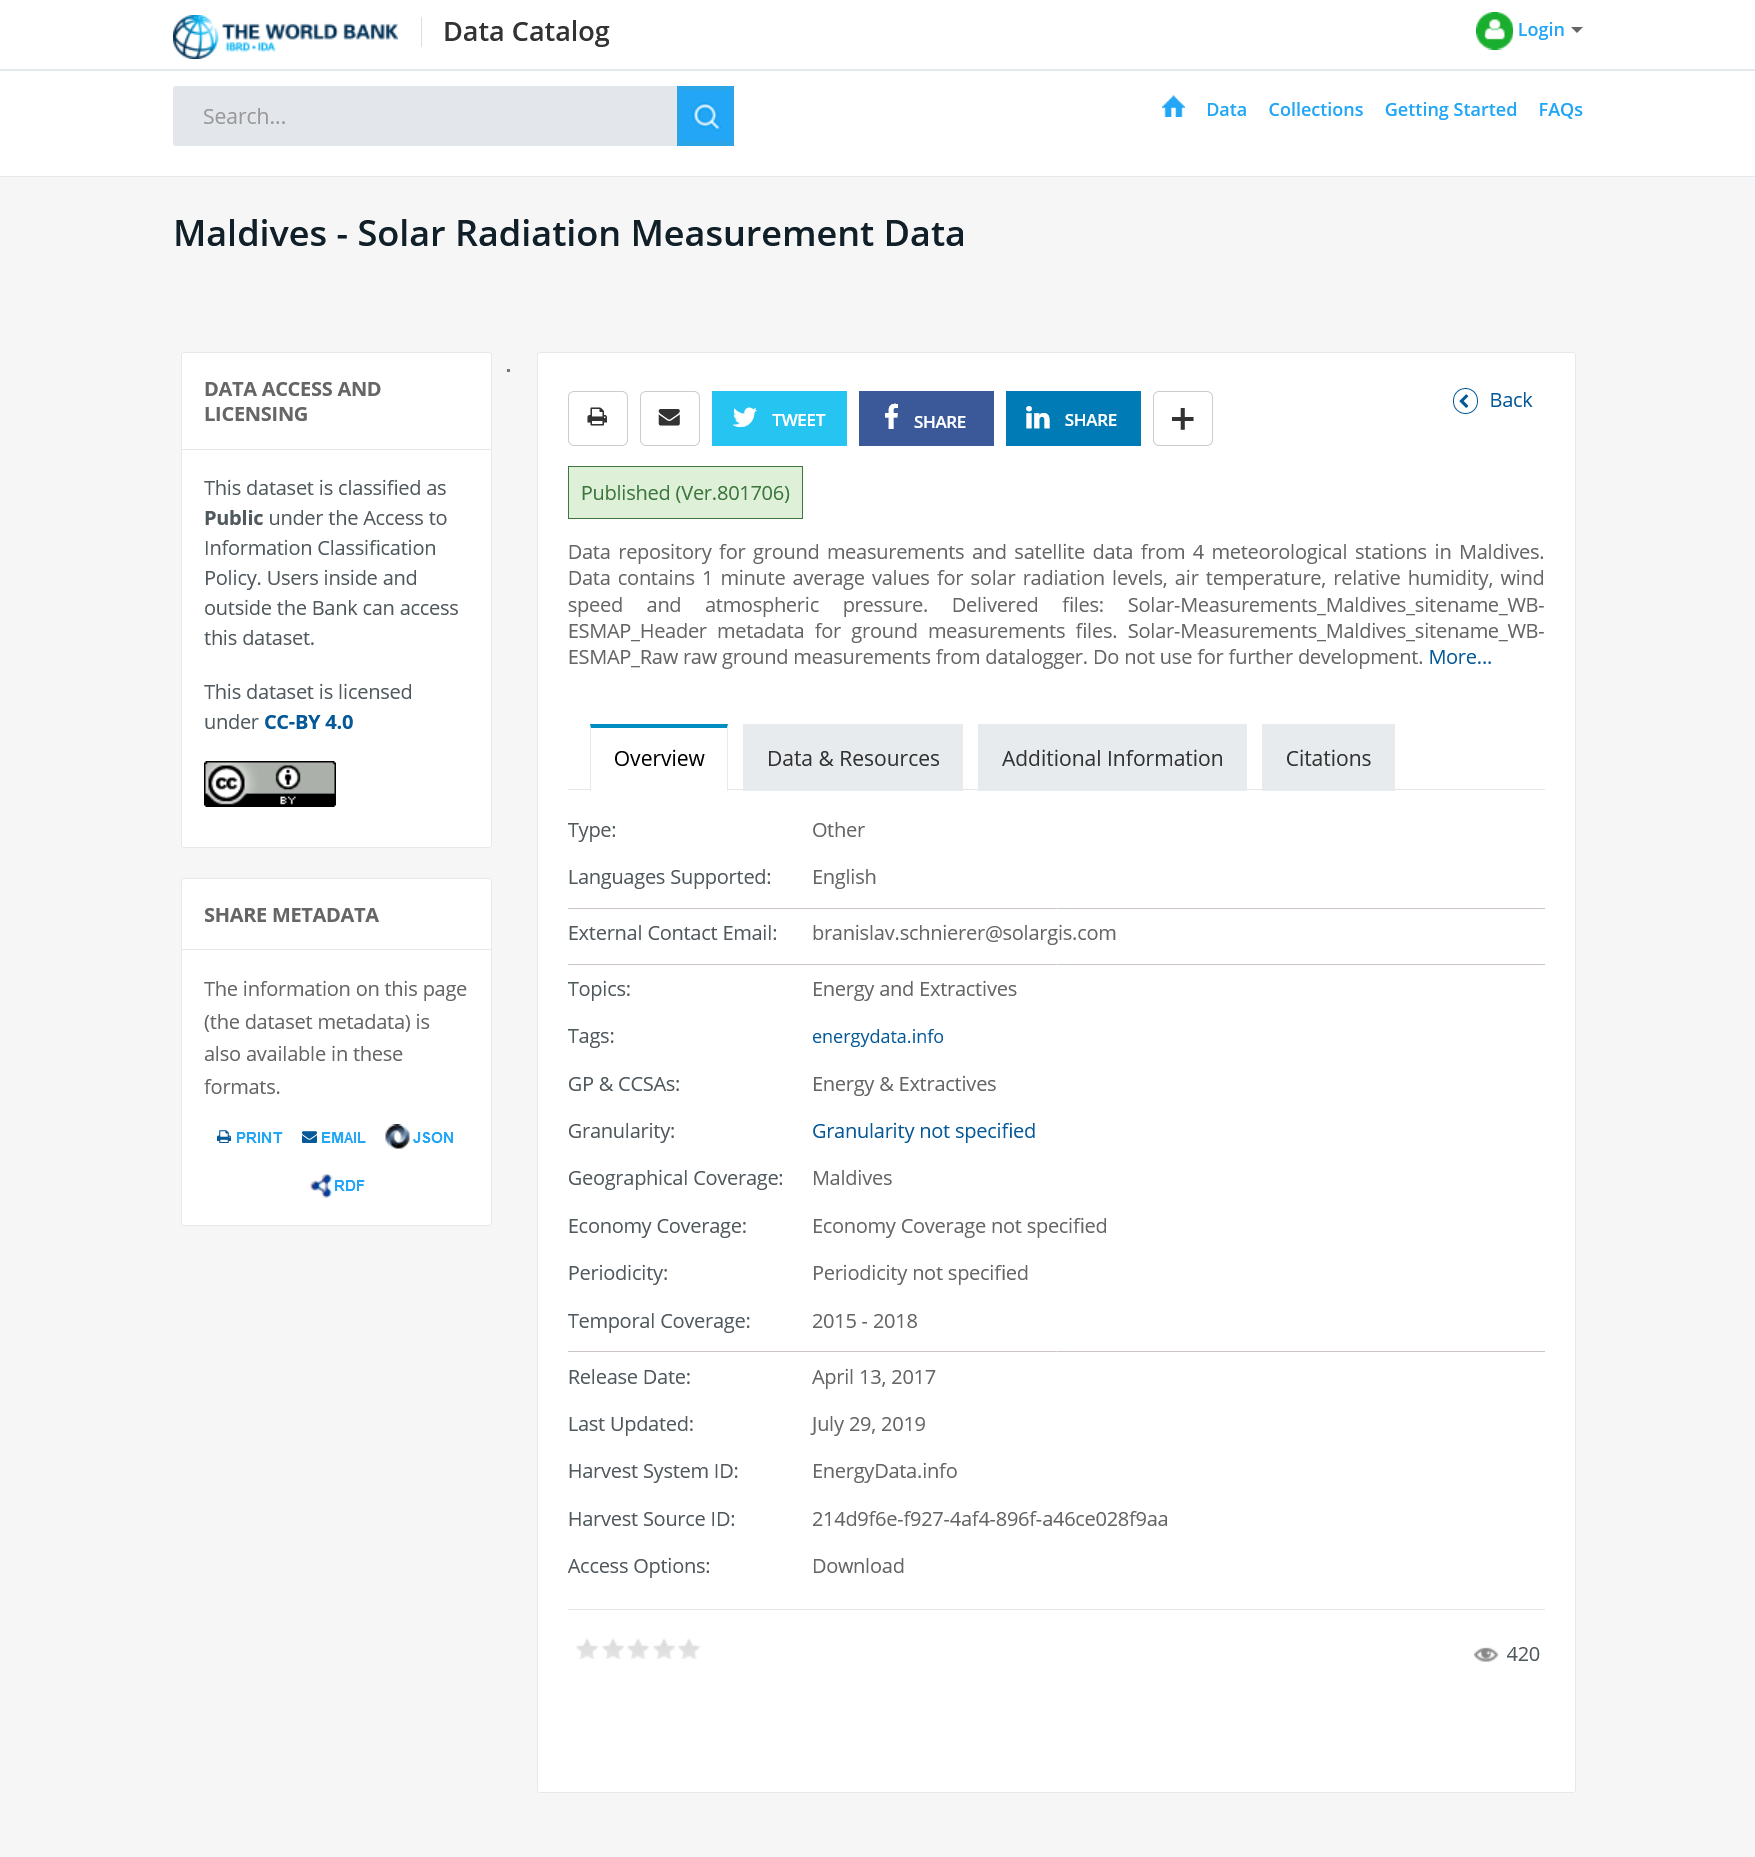Identify some key points in this picture. The data repository for ground measurements and satellite data was collected from four meteorological stations located in Maldives. The dataset can be accessed by users both within and outside the Bank, and it is classified as public, allowing for its sharing via Twitter, Facebook, or LinkedIn. The collected data includes solar radiation measurements. 